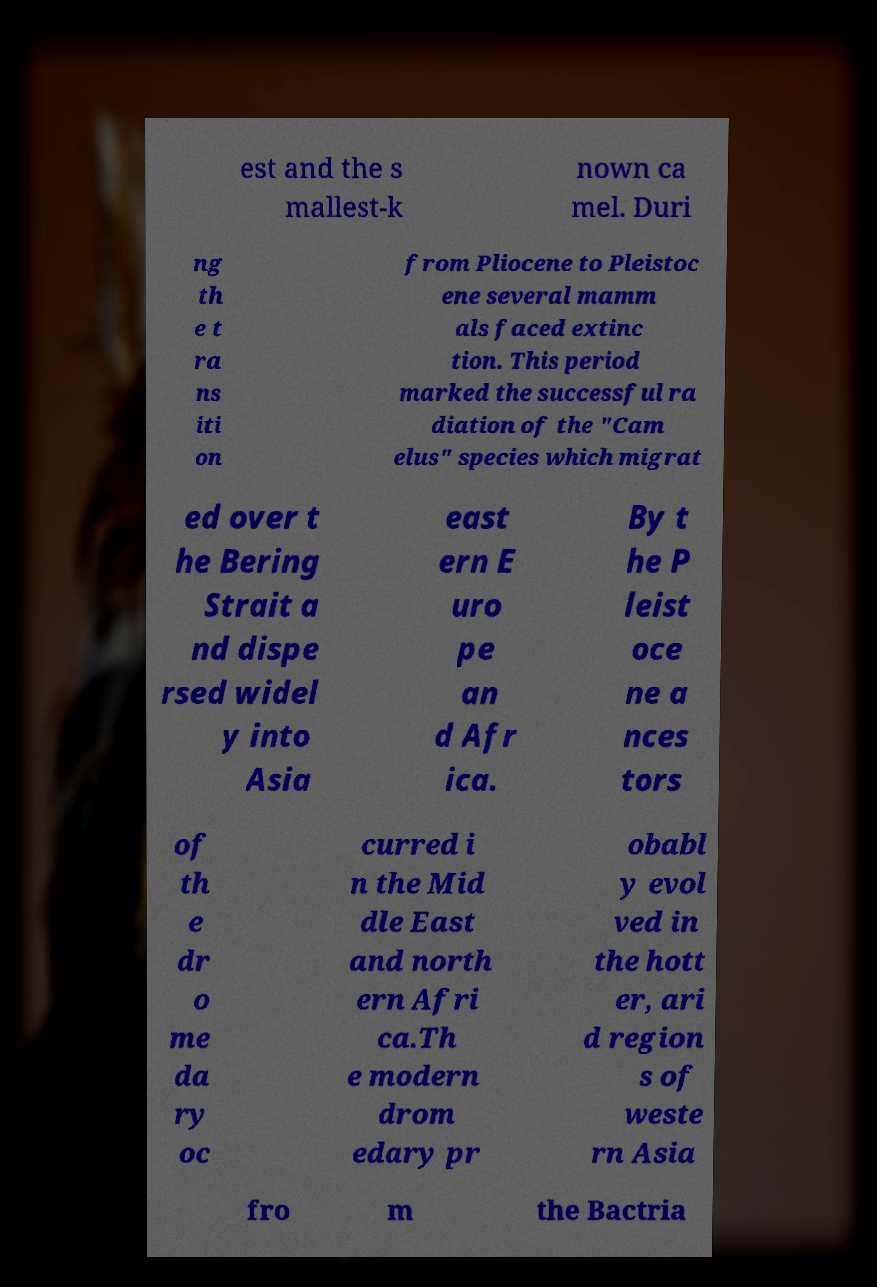What messages or text are displayed in this image? I need them in a readable, typed format. est and the s mallest-k nown ca mel. Duri ng th e t ra ns iti on from Pliocene to Pleistoc ene several mamm als faced extinc tion. This period marked the successful ra diation of the "Cam elus" species which migrat ed over t he Bering Strait a nd dispe rsed widel y into Asia east ern E uro pe an d Afr ica. By t he P leist oce ne a nces tors of th e dr o me da ry oc curred i n the Mid dle East and north ern Afri ca.Th e modern drom edary pr obabl y evol ved in the hott er, ari d region s of weste rn Asia fro m the Bactria 